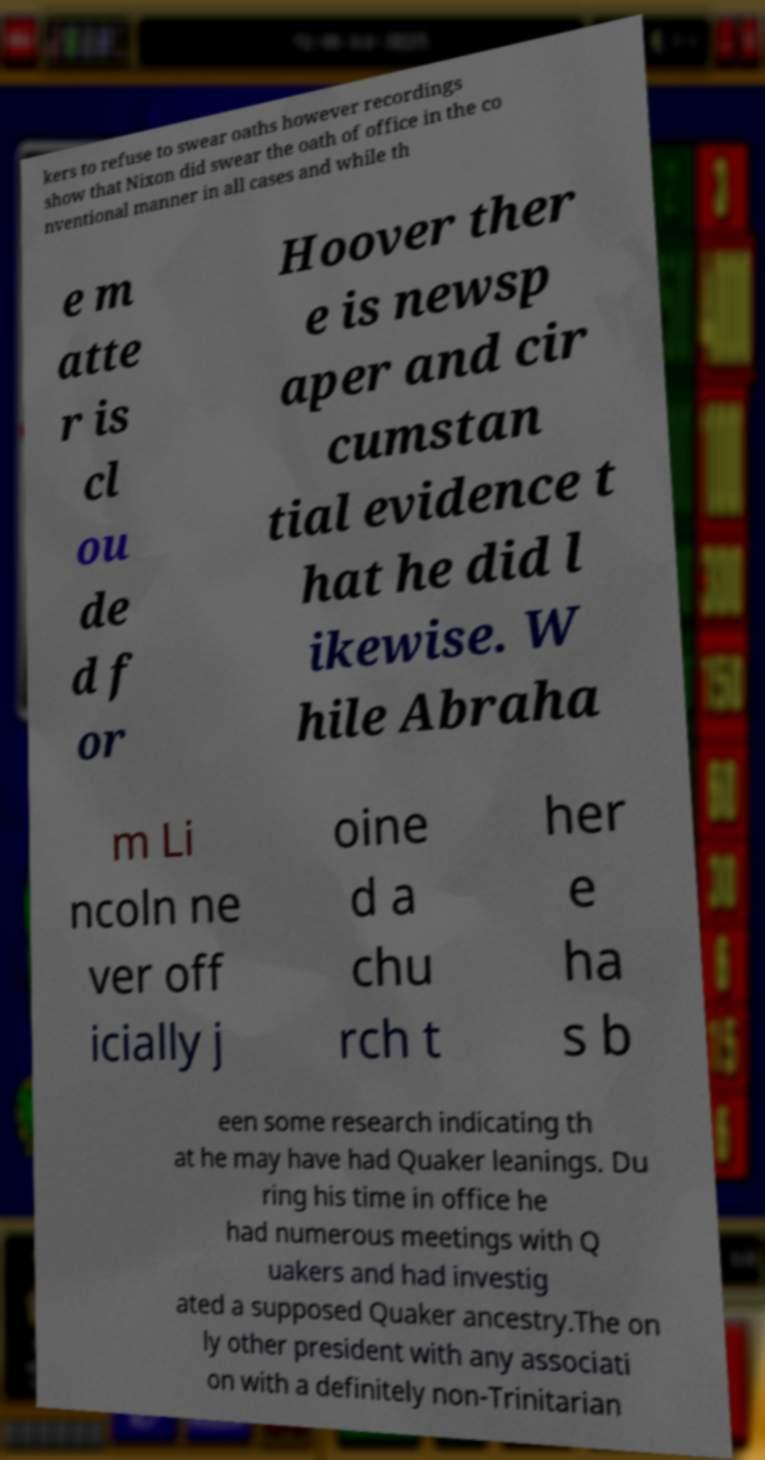There's text embedded in this image that I need extracted. Can you transcribe it verbatim? kers to refuse to swear oaths however recordings show that Nixon did swear the oath of office in the co nventional manner in all cases and while th e m atte r is cl ou de d f or Hoover ther e is newsp aper and cir cumstan tial evidence t hat he did l ikewise. W hile Abraha m Li ncoln ne ver off icially j oine d a chu rch t her e ha s b een some research indicating th at he may have had Quaker leanings. Du ring his time in office he had numerous meetings with Q uakers and had investig ated a supposed Quaker ancestry.The on ly other president with any associati on with a definitely non-Trinitarian 